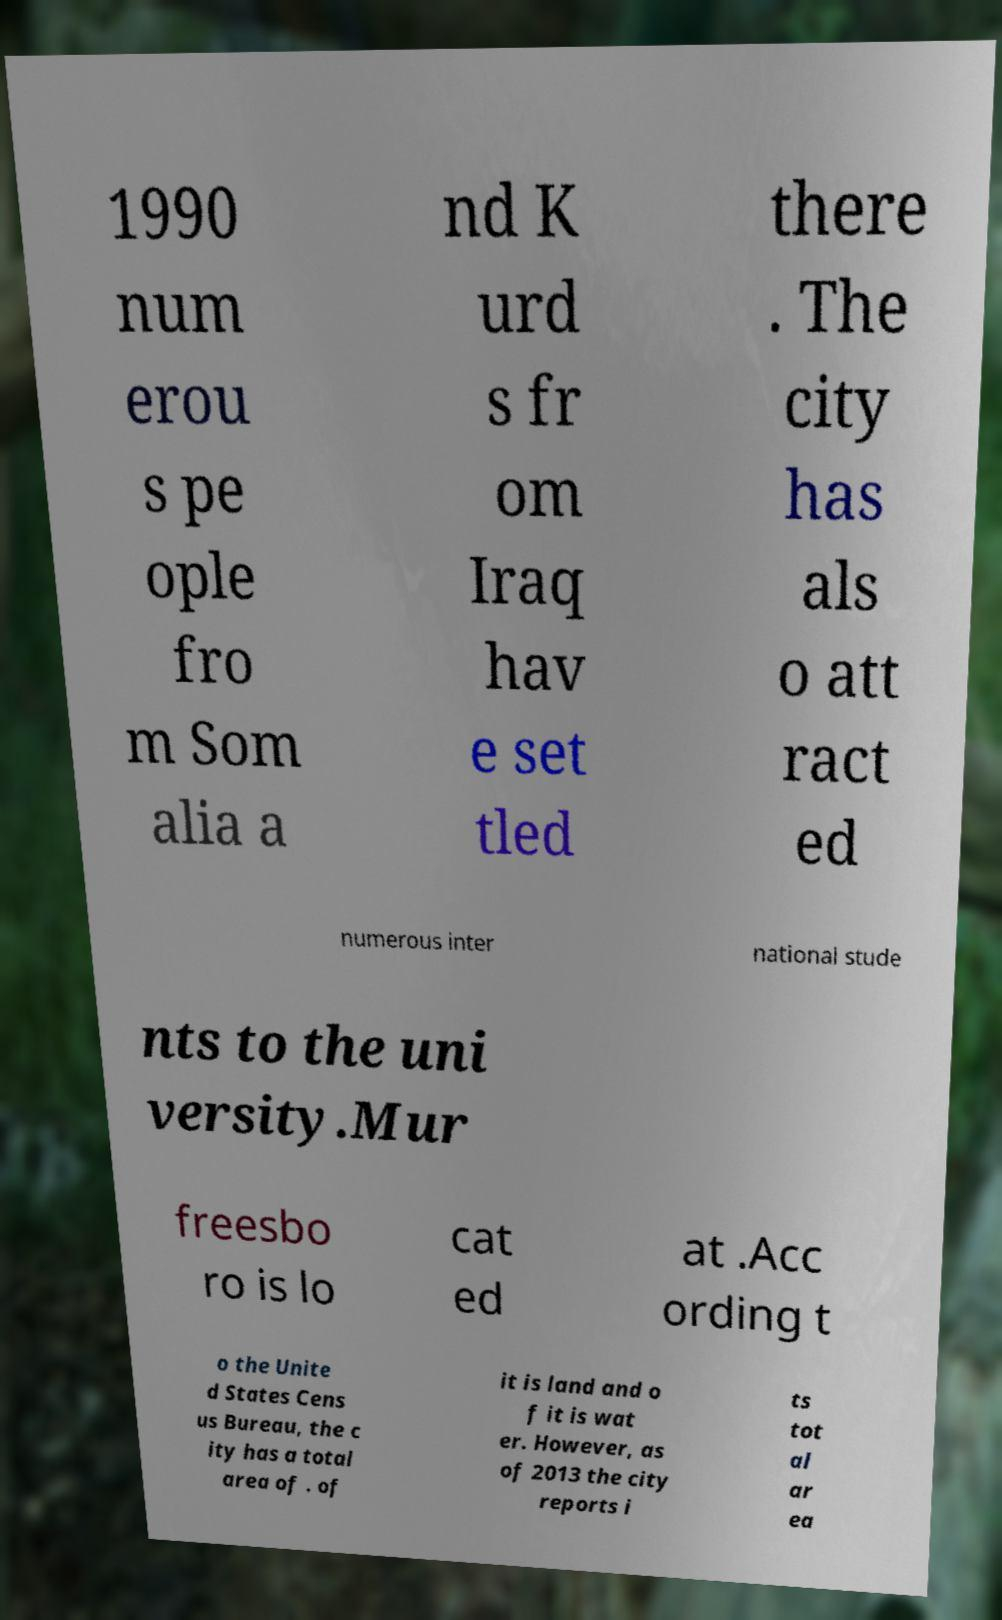There's text embedded in this image that I need extracted. Can you transcribe it verbatim? 1990 num erou s pe ople fro m Som alia a nd K urd s fr om Iraq hav e set tled there . The city has als o att ract ed numerous inter national stude nts to the uni versity.Mur freesbo ro is lo cat ed at .Acc ording t o the Unite d States Cens us Bureau, the c ity has a total area of . of it is land and o f it is wat er. However, as of 2013 the city reports i ts tot al ar ea 